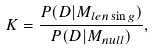<formula> <loc_0><loc_0><loc_500><loc_500>K = \frac { P ( D | M _ { l e n \sin g } ) } { P ( D | M _ { n u l l } ) } ,</formula> 